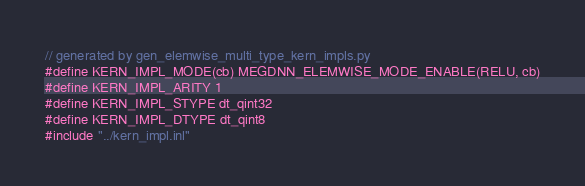<code> <loc_0><loc_0><loc_500><loc_500><_Cuda_>// generated by gen_elemwise_multi_type_kern_impls.py
#define KERN_IMPL_MODE(cb) MEGDNN_ELEMWISE_MODE_ENABLE(RELU, cb)
#define KERN_IMPL_ARITY 1
#define KERN_IMPL_STYPE dt_qint32
#define KERN_IMPL_DTYPE dt_qint8
#include "../kern_impl.inl"
</code> 